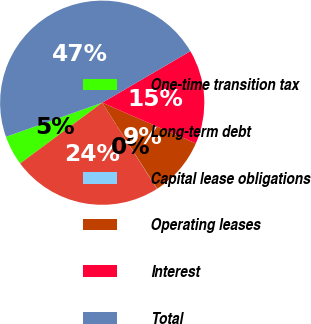Convert chart to OTSL. <chart><loc_0><loc_0><loc_500><loc_500><pie_chart><fcel>One-time transition tax<fcel>Long-term debt<fcel>Capital lease obligations<fcel>Operating leases<fcel>Interest<fcel>Total<nl><fcel>4.73%<fcel>23.87%<fcel>0.03%<fcel>9.42%<fcel>14.95%<fcel>46.99%<nl></chart> 